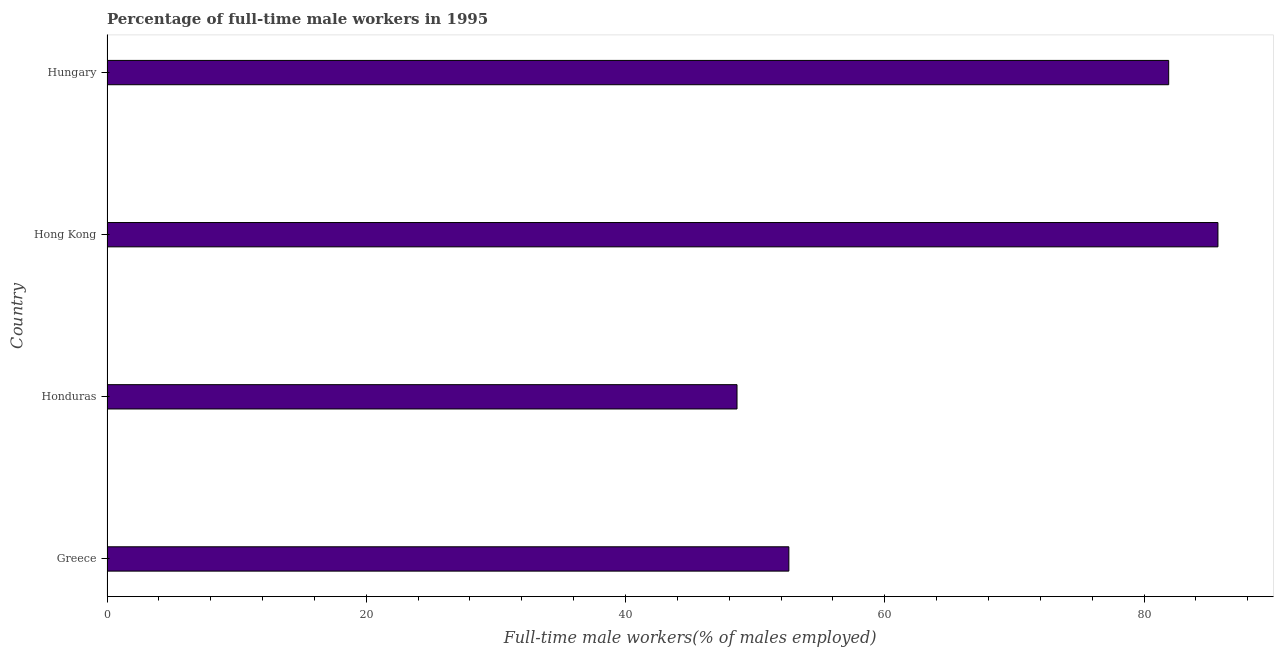What is the title of the graph?
Provide a short and direct response. Percentage of full-time male workers in 1995. What is the label or title of the X-axis?
Your answer should be compact. Full-time male workers(% of males employed). What is the percentage of full-time male workers in Hong Kong?
Provide a short and direct response. 85.7. Across all countries, what is the maximum percentage of full-time male workers?
Provide a succinct answer. 85.7. Across all countries, what is the minimum percentage of full-time male workers?
Offer a very short reply. 48.6. In which country was the percentage of full-time male workers maximum?
Provide a short and direct response. Hong Kong. In which country was the percentage of full-time male workers minimum?
Provide a succinct answer. Honduras. What is the sum of the percentage of full-time male workers?
Provide a succinct answer. 268.8. What is the difference between the percentage of full-time male workers in Hong Kong and Hungary?
Provide a short and direct response. 3.8. What is the average percentage of full-time male workers per country?
Provide a short and direct response. 67.2. What is the median percentage of full-time male workers?
Your answer should be compact. 67.25. What is the ratio of the percentage of full-time male workers in Greece to that in Hungary?
Offer a terse response. 0.64. Is the percentage of full-time male workers in Hong Kong less than that in Hungary?
Your answer should be very brief. No. Is the difference between the percentage of full-time male workers in Greece and Hungary greater than the difference between any two countries?
Ensure brevity in your answer.  No. What is the difference between the highest and the second highest percentage of full-time male workers?
Provide a short and direct response. 3.8. Is the sum of the percentage of full-time male workers in Greece and Hong Kong greater than the maximum percentage of full-time male workers across all countries?
Offer a very short reply. Yes. What is the difference between the highest and the lowest percentage of full-time male workers?
Provide a short and direct response. 37.1. In how many countries, is the percentage of full-time male workers greater than the average percentage of full-time male workers taken over all countries?
Offer a terse response. 2. Are all the bars in the graph horizontal?
Offer a very short reply. Yes. How many countries are there in the graph?
Offer a very short reply. 4. Are the values on the major ticks of X-axis written in scientific E-notation?
Your answer should be very brief. No. What is the Full-time male workers(% of males employed) of Greece?
Your answer should be very brief. 52.6. What is the Full-time male workers(% of males employed) in Honduras?
Ensure brevity in your answer.  48.6. What is the Full-time male workers(% of males employed) in Hong Kong?
Keep it short and to the point. 85.7. What is the Full-time male workers(% of males employed) in Hungary?
Your answer should be compact. 81.9. What is the difference between the Full-time male workers(% of males employed) in Greece and Honduras?
Make the answer very short. 4. What is the difference between the Full-time male workers(% of males employed) in Greece and Hong Kong?
Offer a terse response. -33.1. What is the difference between the Full-time male workers(% of males employed) in Greece and Hungary?
Give a very brief answer. -29.3. What is the difference between the Full-time male workers(% of males employed) in Honduras and Hong Kong?
Keep it short and to the point. -37.1. What is the difference between the Full-time male workers(% of males employed) in Honduras and Hungary?
Your answer should be compact. -33.3. What is the difference between the Full-time male workers(% of males employed) in Hong Kong and Hungary?
Your answer should be very brief. 3.8. What is the ratio of the Full-time male workers(% of males employed) in Greece to that in Honduras?
Offer a terse response. 1.08. What is the ratio of the Full-time male workers(% of males employed) in Greece to that in Hong Kong?
Give a very brief answer. 0.61. What is the ratio of the Full-time male workers(% of males employed) in Greece to that in Hungary?
Your answer should be compact. 0.64. What is the ratio of the Full-time male workers(% of males employed) in Honduras to that in Hong Kong?
Give a very brief answer. 0.57. What is the ratio of the Full-time male workers(% of males employed) in Honduras to that in Hungary?
Keep it short and to the point. 0.59. What is the ratio of the Full-time male workers(% of males employed) in Hong Kong to that in Hungary?
Your answer should be compact. 1.05. 